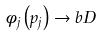<formula> <loc_0><loc_0><loc_500><loc_500>\phi _ { j } \left ( p _ { j } \right ) \rightarrow b D</formula> 